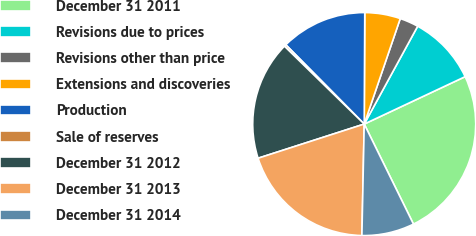<chart> <loc_0><loc_0><loc_500><loc_500><pie_chart><fcel>December 31 2011<fcel>Revisions due to prices<fcel>Revisions other than price<fcel>Extensions and discoveries<fcel>Production<fcel>Sale of reserves<fcel>December 31 2012<fcel>December 31 2013<fcel>December 31 2014<nl><fcel>24.71%<fcel>10.05%<fcel>2.72%<fcel>5.16%<fcel>12.49%<fcel>0.28%<fcel>17.26%<fcel>19.71%<fcel>7.61%<nl></chart> 